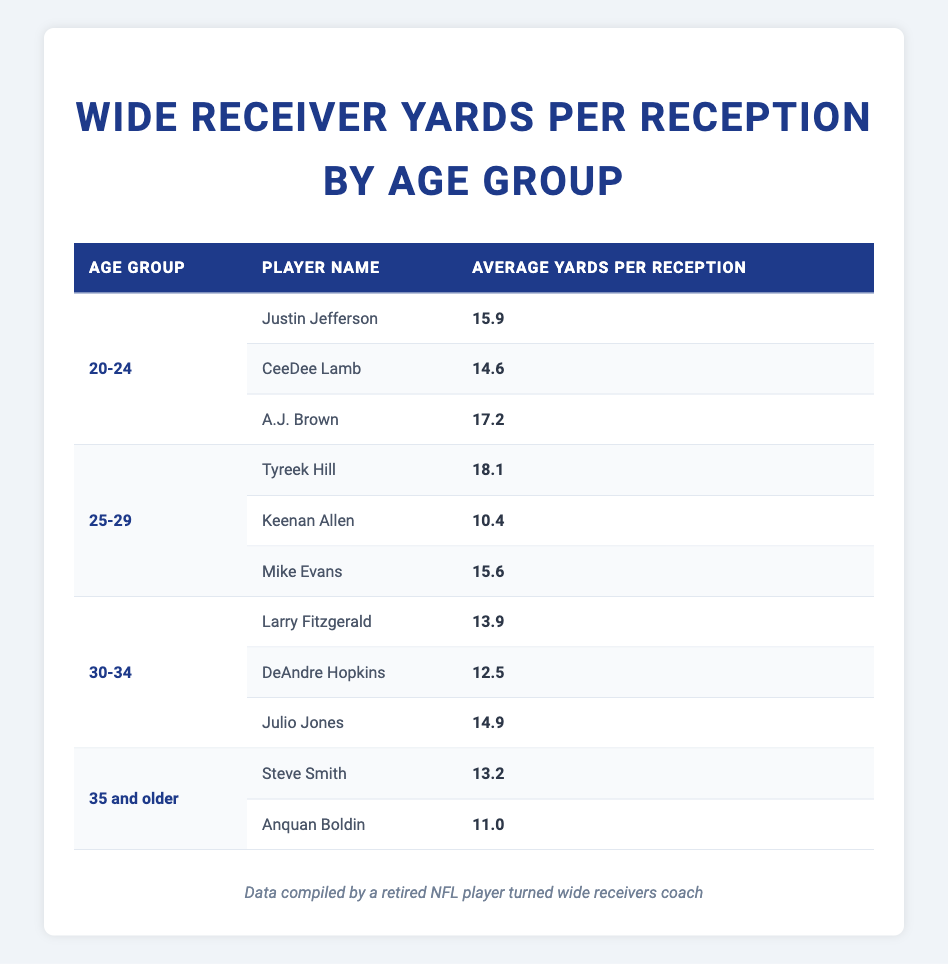What is the average yards gained per reception by players aged 20-24? The average yards for the age group 20-24 can be calculated by summing up their average yards: 15.9 (Justin Jefferson) + 14.6 (CeeDee Lamb) + 17.2 (A.J. Brown) = 47.7. Then divide by the number of players, which is 3: 47.7 / 3 = 15.9.
Answer: 15.9 Which player has the highest average yards per reception in the table? By examining the average yards per reception of each player, the highest value is 18.1 from Tyreek Hill.
Answer: Tyreek Hill Is the average yards per reception for players aged 35 and older greater than that of players aged 30-34? For the 35 and older group, their maximum value (Steve Smith) is 13.2 and the minimum (Anquan Boldin) is 11.0, averaging to 12.1. For the 30-34 group, the maximum is 14.9 (Julio Jones) and minimum is 12.5 (DeAndre Hopkins), averaging to 13.8. Therefore, 12.1 is less than 13.8 which means the 35 and older group has a lower average.
Answer: No What is the median average yards gained per reception across all age groups? To find the median, we first list the averages in ascending order: 10.4, 11.0, 12.5, 13.2, 13.9, 14.6, 14.9, 15.6, 15.9, 17.2, 18.1. With 11 values, the median is the 6th value: 14.6.
Answer: 14.6 Does A.J. Brown have a higher average yards per reception than Julio Jones? A.J. Brown's average is 17.2 while Julio Jones has 14.9. Since 17.2 is greater than 14.9, A.J. Brown has a higher average.
Answer: Yes What is the difference in average yards per reception between the age group 25-29 and 30-34? The average yards for 25-29 is: (18.1 + 10.4 + 15.6) / 3 = 14.67. For 30-34: (13.9 + 12.5 + 14.9) / 3 = 13.73. The difference is 14.67 - 13.73 = 0.94.
Answer: 0.94 Who are the players in the age group 30-34? The players in this age group are Larry Fitzgerald, DeAndre Hopkins, and Julio Jones. Their average yards are displayed clearly in the table.
Answer: Larry Fitzgerald, DeAndre Hopkins, Julio Jones Which age group has the lowest average yards per reception? To determine this, we calculate the average for each group: 20-24 = 15.9, 25-29 = 14.67, 30-34 = 13.73, and 35 and older = 12.1. The lowest average is from the 35 and older group, which has an average of 12.1 yards.
Answer: 35 and older 